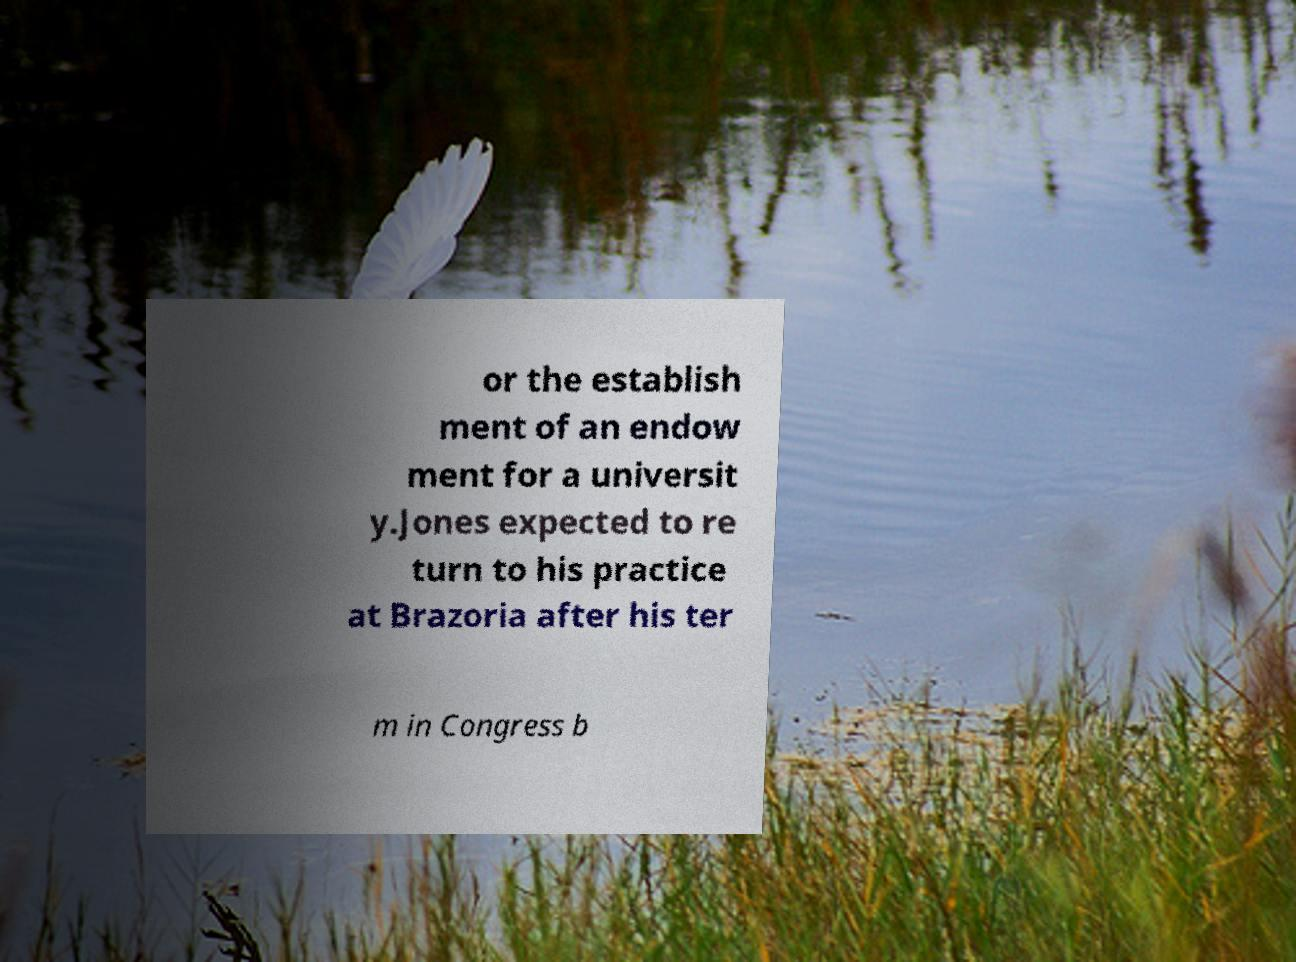For documentation purposes, I need the text within this image transcribed. Could you provide that? or the establish ment of an endow ment for a universit y.Jones expected to re turn to his practice at Brazoria after his ter m in Congress b 